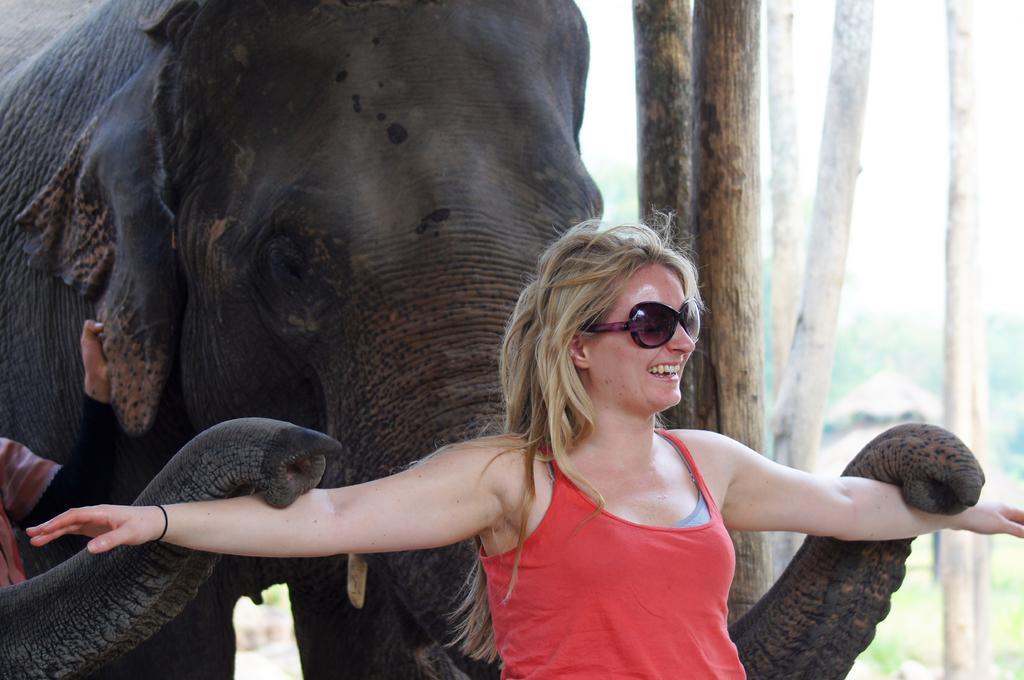In one or two sentences, can you explain what this image depicts? In the middle of the image a woman is standing and smiling. Behind her there is a elephant and there are some trees. 